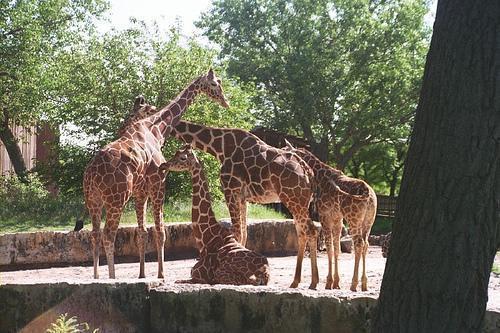How many giraffes are standing in the middle of the stone enclosure?
Choose the right answer from the provided options to respond to the question.
Options: One, two, three, four. Four. 